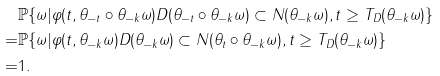<formula> <loc_0><loc_0><loc_500><loc_500>& \mathbb { P } \{ \omega | \varphi ( t , \theta _ { - t } \circ \theta _ { - k } \omega ) D ( \theta _ { - t } \circ \theta _ { - k } \omega ) \subset N ( \theta _ { - k } \omega ) , t \geq T _ { D } ( \theta _ { - k } \omega ) \} \\ = & \mathbb { P } \{ \omega | \varphi ( t , \theta _ { - k } \omega ) D ( \theta _ { - k } \omega ) \subset N ( \theta _ { t } \circ \theta _ { - k } \omega ) , t \geq T _ { D } ( \theta _ { - k } \omega ) \} \\ = & 1 .</formula> 